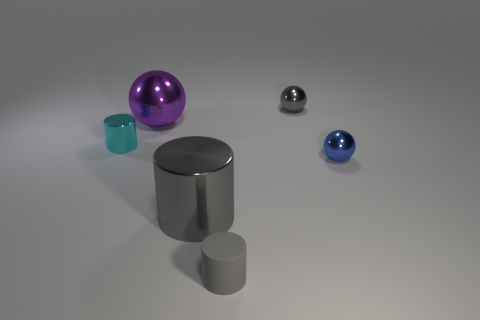Does the small cylinder in front of the large cylinder have the same material as the tiny cylinder left of the big purple metallic object? No, the materials appear to be different. The small cylinder in front of the large cylinder has a matte finish suggesting it could be made of a non-metallic material, while the tiny cylinder to the left of the large purple metallic object has a reflective surface similar to metal. 